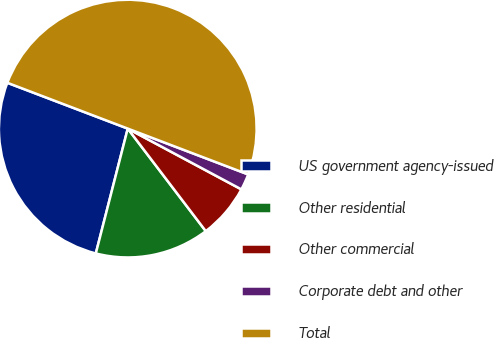Convert chart. <chart><loc_0><loc_0><loc_500><loc_500><pie_chart><fcel>US government agency-issued<fcel>Other residential<fcel>Other commercial<fcel>Corporate debt and other<fcel>Total<nl><fcel>26.8%<fcel>14.34%<fcel>6.83%<fcel>2.03%<fcel>50.0%<nl></chart> 